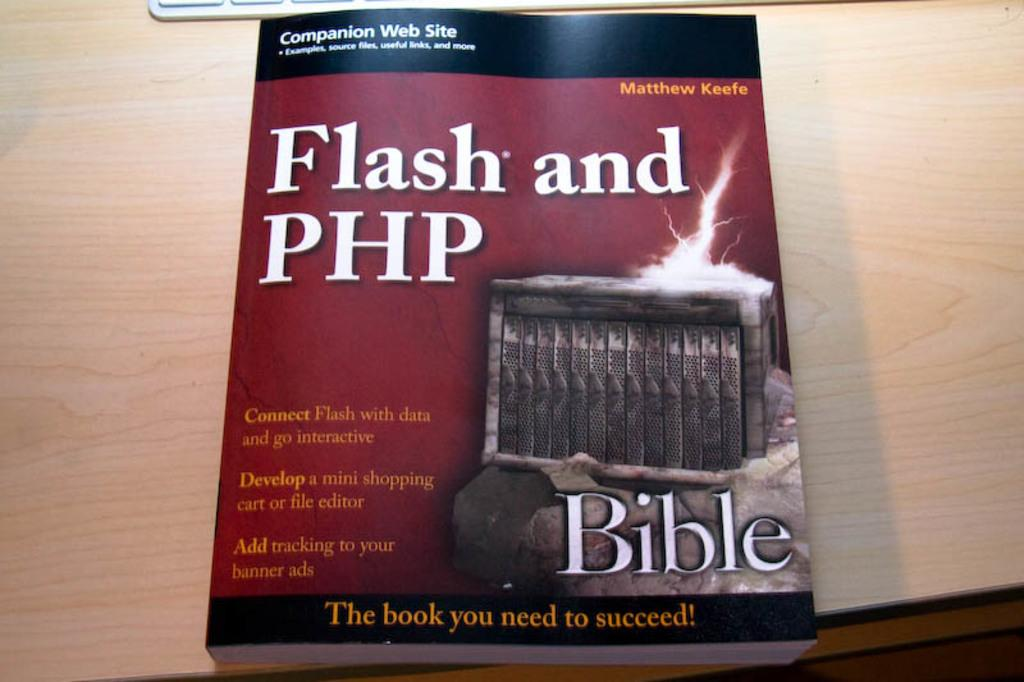<image>
Give a short and clear explanation of the subsequent image. A red book cover has the word bible on it in large white print. 